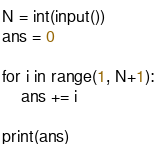<code> <loc_0><loc_0><loc_500><loc_500><_Python_>N = int(input())
ans = 0

for i in range(1, N+1):
    ans += i

print(ans)
</code> 